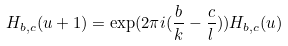Convert formula to latex. <formula><loc_0><loc_0><loc_500><loc_500>H _ { b , c } ( u + 1 ) = \exp ( 2 \pi i ( \frac { b } { k } - \frac { c } { l } ) ) H _ { b , c } ( u )</formula> 